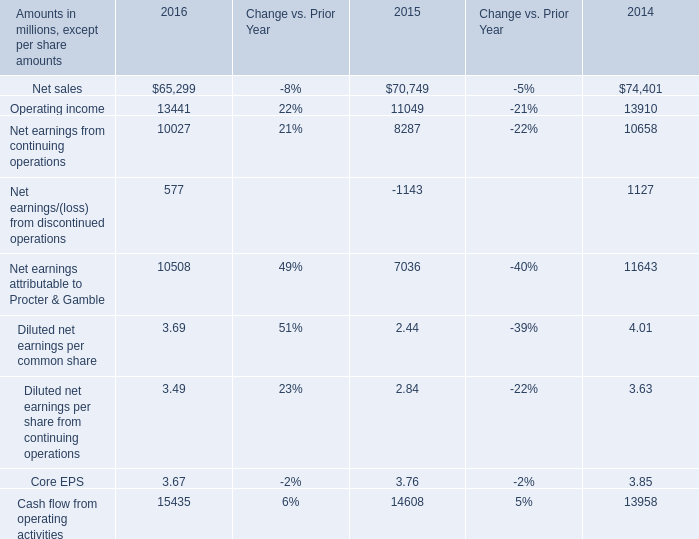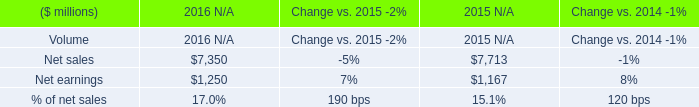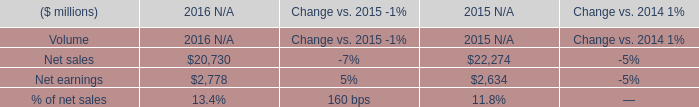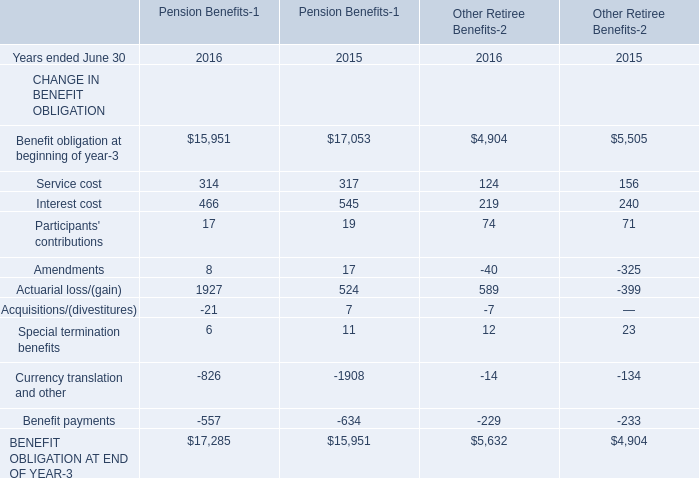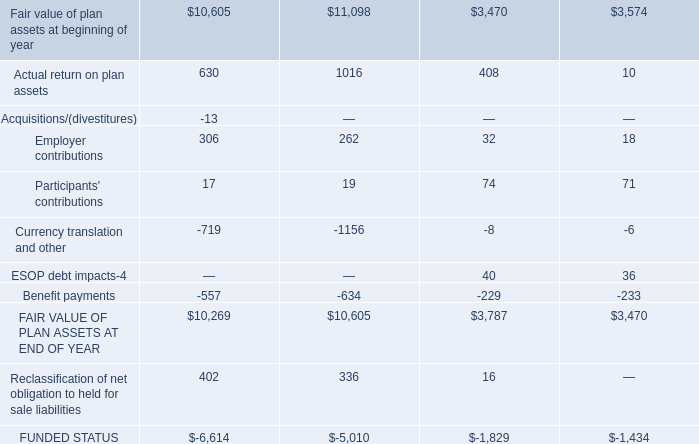what's the total amount of Fair value of plan assets at beginning of year, Cash flow from operating activities of 2016, and BENEFIT OBLIGATION AT END OF YEAR of Other Retiree Benefits 2015 ? 
Computations: ((3470.0 + 15435.0) + 4904.0)
Answer: 23809.0. 